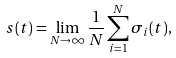<formula> <loc_0><loc_0><loc_500><loc_500>s ( t ) = \lim _ { N \rightarrow \infty } \frac { 1 } { N } \sum _ { i = 1 } ^ { N } \sigma _ { i } ( t ) ,</formula> 